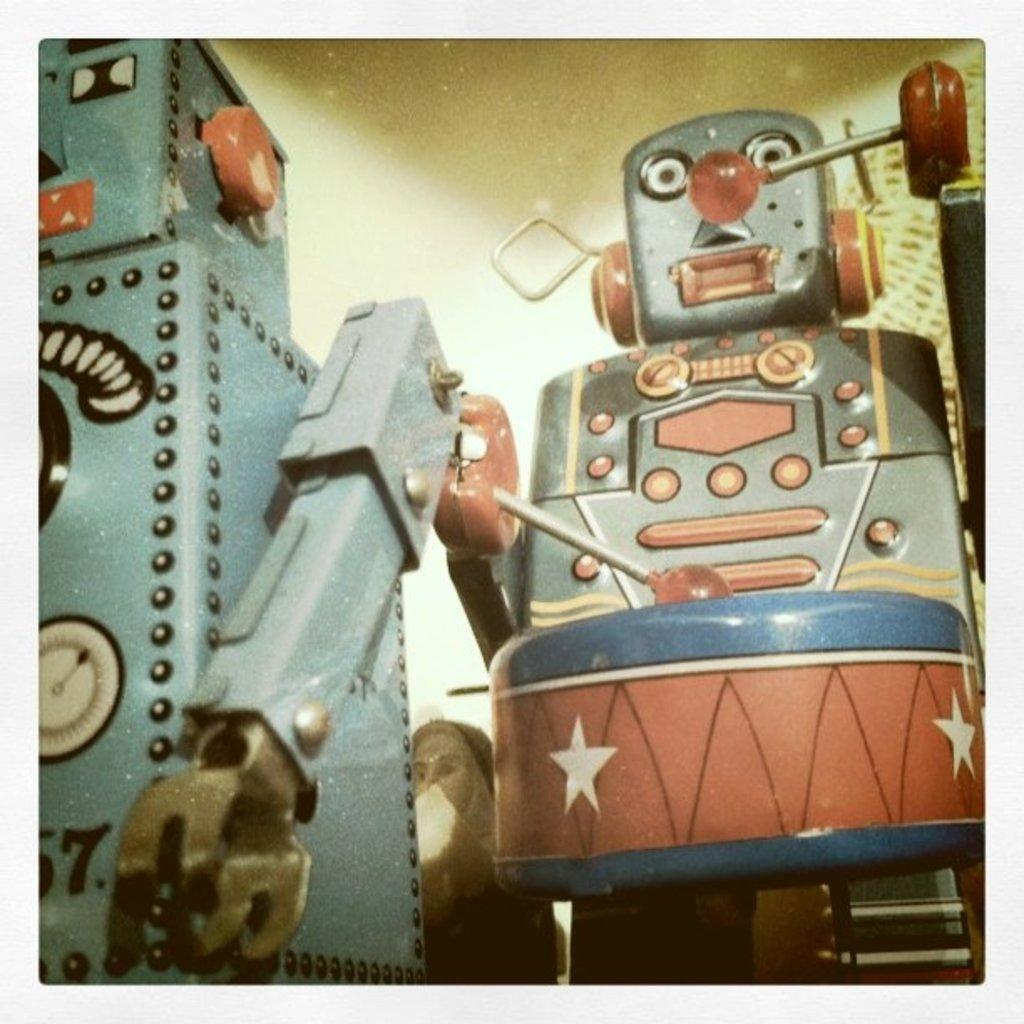What type of objects or figures can be seen in the image? There are robots in the image. What books are the robots reading during dinner in the image? There are no books or dinner depicted in the image; it only features robots. 